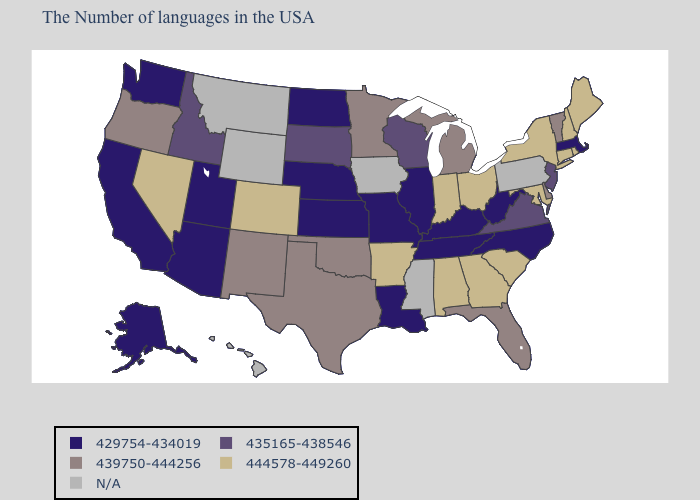What is the highest value in the Northeast ?
Write a very short answer. 444578-449260. What is the lowest value in the South?
Give a very brief answer. 429754-434019. Name the states that have a value in the range 435165-438546?
Write a very short answer. New Jersey, Virginia, Wisconsin, South Dakota, Idaho. Does the map have missing data?
Quick response, please. Yes. What is the value of Alaska?
Quick response, please. 429754-434019. What is the highest value in the USA?
Concise answer only. 444578-449260. What is the value of Iowa?
Answer briefly. N/A. What is the value of Rhode Island?
Write a very short answer. 444578-449260. Which states have the lowest value in the USA?
Give a very brief answer. Massachusetts, North Carolina, West Virginia, Kentucky, Tennessee, Illinois, Louisiana, Missouri, Kansas, Nebraska, North Dakota, Utah, Arizona, California, Washington, Alaska. What is the value of Michigan?
Concise answer only. 439750-444256. What is the value of Maryland?
Write a very short answer. 444578-449260. Among the states that border Colorado , does Utah have the lowest value?
Concise answer only. Yes. Does California have the highest value in the USA?
Give a very brief answer. No. What is the highest value in the USA?
Write a very short answer. 444578-449260. 